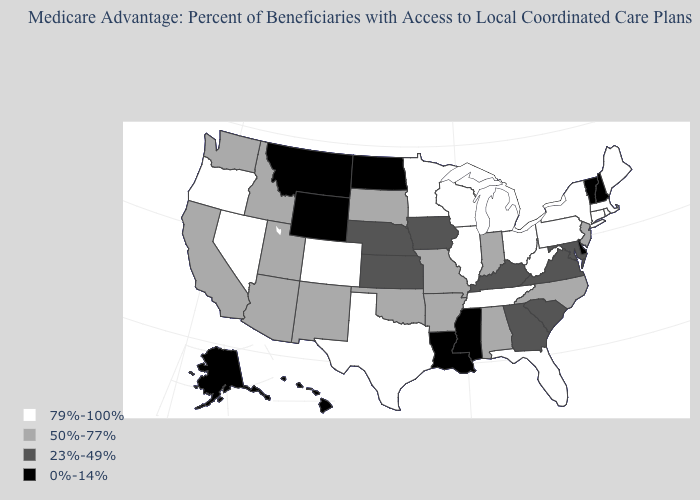Which states hav the highest value in the South?
Quick response, please. Florida, Tennessee, Texas, West Virginia. Does the first symbol in the legend represent the smallest category?
Keep it brief. No. What is the value of Rhode Island?
Short answer required. 79%-100%. Does the first symbol in the legend represent the smallest category?
Quick response, please. No. Does the first symbol in the legend represent the smallest category?
Be succinct. No. Does the first symbol in the legend represent the smallest category?
Answer briefly. No. What is the value of California?
Keep it brief. 50%-77%. What is the lowest value in states that border Montana?
Concise answer only. 0%-14%. Does Louisiana have a higher value than Washington?
Concise answer only. No. What is the highest value in states that border Rhode Island?
Give a very brief answer. 79%-100%. Name the states that have a value in the range 0%-14%?
Keep it brief. Delaware, Hawaii, Louisiana, Mississippi, Montana, North Dakota, New Hampshire, Alaska, Vermont, Wyoming. Among the states that border Oregon , does California have the lowest value?
Answer briefly. Yes. Among the states that border South Carolina , does North Carolina have the highest value?
Keep it brief. Yes. What is the value of Michigan?
Concise answer only. 79%-100%. Does West Virginia have the highest value in the USA?
Write a very short answer. Yes. 